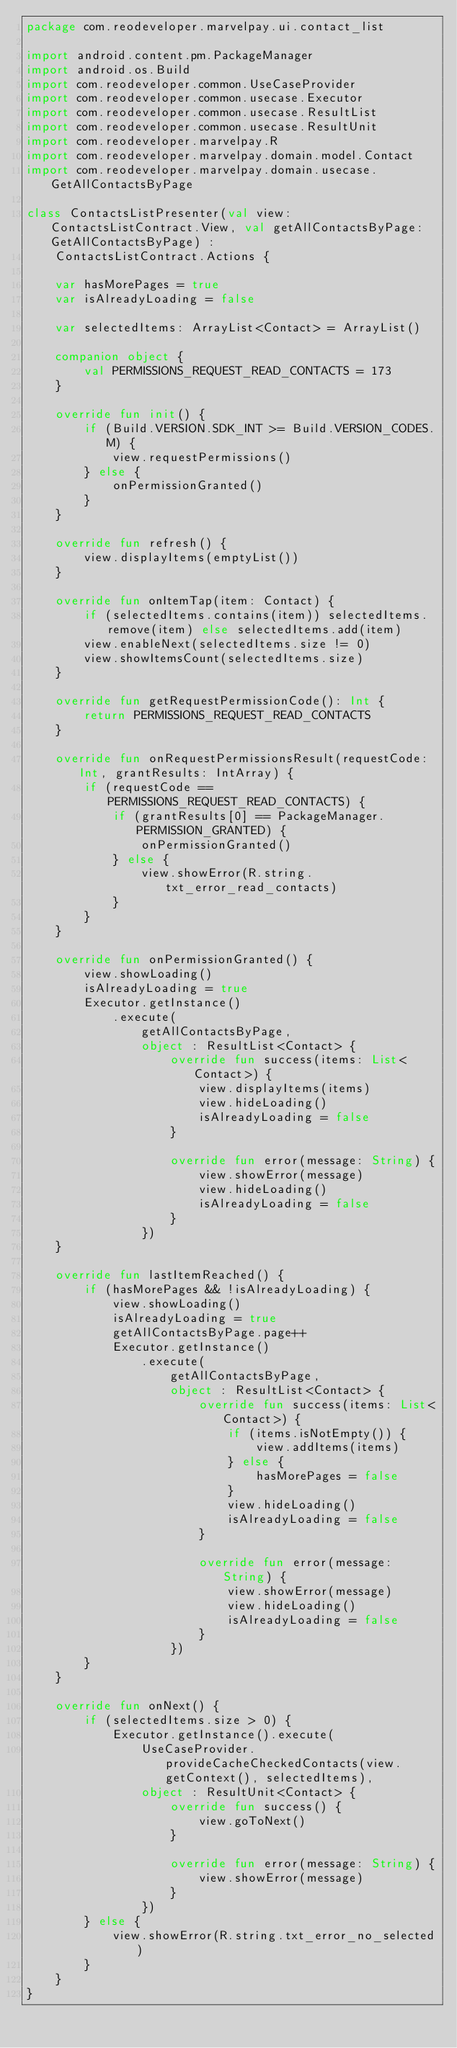Convert code to text. <code><loc_0><loc_0><loc_500><loc_500><_Kotlin_>package com.reodeveloper.marvelpay.ui.contact_list

import android.content.pm.PackageManager
import android.os.Build
import com.reodeveloper.common.UseCaseProvider
import com.reodeveloper.common.usecase.Executor
import com.reodeveloper.common.usecase.ResultList
import com.reodeveloper.common.usecase.ResultUnit
import com.reodeveloper.marvelpay.R
import com.reodeveloper.marvelpay.domain.model.Contact
import com.reodeveloper.marvelpay.domain.usecase.GetAllContactsByPage

class ContactsListPresenter(val view: ContactsListContract.View, val getAllContactsByPage: GetAllContactsByPage) :
    ContactsListContract.Actions {

    var hasMorePages = true
    var isAlreadyLoading = false

    var selectedItems: ArrayList<Contact> = ArrayList()

    companion object {
        val PERMISSIONS_REQUEST_READ_CONTACTS = 173
    }

    override fun init() {
        if (Build.VERSION.SDK_INT >= Build.VERSION_CODES.M) {
            view.requestPermissions()
        } else {
            onPermissionGranted()
        }
    }

    override fun refresh() {
        view.displayItems(emptyList())
    }

    override fun onItemTap(item: Contact) {
        if (selectedItems.contains(item)) selectedItems.remove(item) else selectedItems.add(item)
        view.enableNext(selectedItems.size != 0)
        view.showItemsCount(selectedItems.size)
    }

    override fun getRequestPermissionCode(): Int {
        return PERMISSIONS_REQUEST_READ_CONTACTS
    }

    override fun onRequestPermissionsResult(requestCode: Int, grantResults: IntArray) {
        if (requestCode == PERMISSIONS_REQUEST_READ_CONTACTS) {
            if (grantResults[0] == PackageManager.PERMISSION_GRANTED) {
                onPermissionGranted()
            } else {
                view.showError(R.string.txt_error_read_contacts)
            }
        }
    }

    override fun onPermissionGranted() {
        view.showLoading()
        isAlreadyLoading = true
        Executor.getInstance()
            .execute(
                getAllContactsByPage,
                object : ResultList<Contact> {
                    override fun success(items: List<Contact>) {
                        view.displayItems(items)
                        view.hideLoading()
                        isAlreadyLoading = false
                    }

                    override fun error(message: String) {
                        view.showError(message)
                        view.hideLoading()
                        isAlreadyLoading = false
                    }
                })
    }

    override fun lastItemReached() {
        if (hasMorePages && !isAlreadyLoading) {
            view.showLoading()
            isAlreadyLoading = true
            getAllContactsByPage.page++
            Executor.getInstance()
                .execute(
                    getAllContactsByPage,
                    object : ResultList<Contact> {
                        override fun success(items: List<Contact>) {
                            if (items.isNotEmpty()) {
                                view.addItems(items)
                            } else {
                                hasMorePages = false
                            }
                            view.hideLoading()
                            isAlreadyLoading = false
                        }

                        override fun error(message: String) {
                            view.showError(message)
                            view.hideLoading()
                            isAlreadyLoading = false
                        }
                    })
        }
    }

    override fun onNext() {
        if (selectedItems.size > 0) {
            Executor.getInstance().execute(
                UseCaseProvider.provideCacheCheckedContacts(view.getContext(), selectedItems),
                object : ResultUnit<Contact> {
                    override fun success() {
                        view.goToNext()
                    }

                    override fun error(message: String) {
                        view.showError(message)
                    }
                })
        } else {
            view.showError(R.string.txt_error_no_selected)
        }
    }
}</code> 